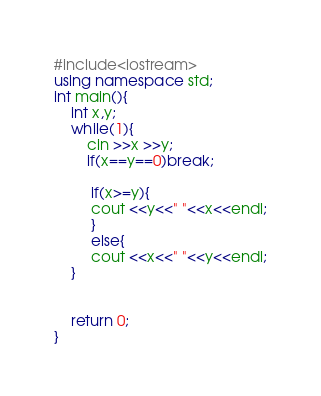Convert code to text. <code><loc_0><loc_0><loc_500><loc_500><_C++_>#include<iostream>
using namespace std;
int main(){
    int x,y;
    while(1){
        cin >>x >>y;
        if(x==y==0)break;
         
         if(x>=y){
         cout <<y<<" "<<x<<endl;
         }
         else{
         cout <<x<<" "<<y<<endl;
    }
   
    
    return 0;
}
</code> 